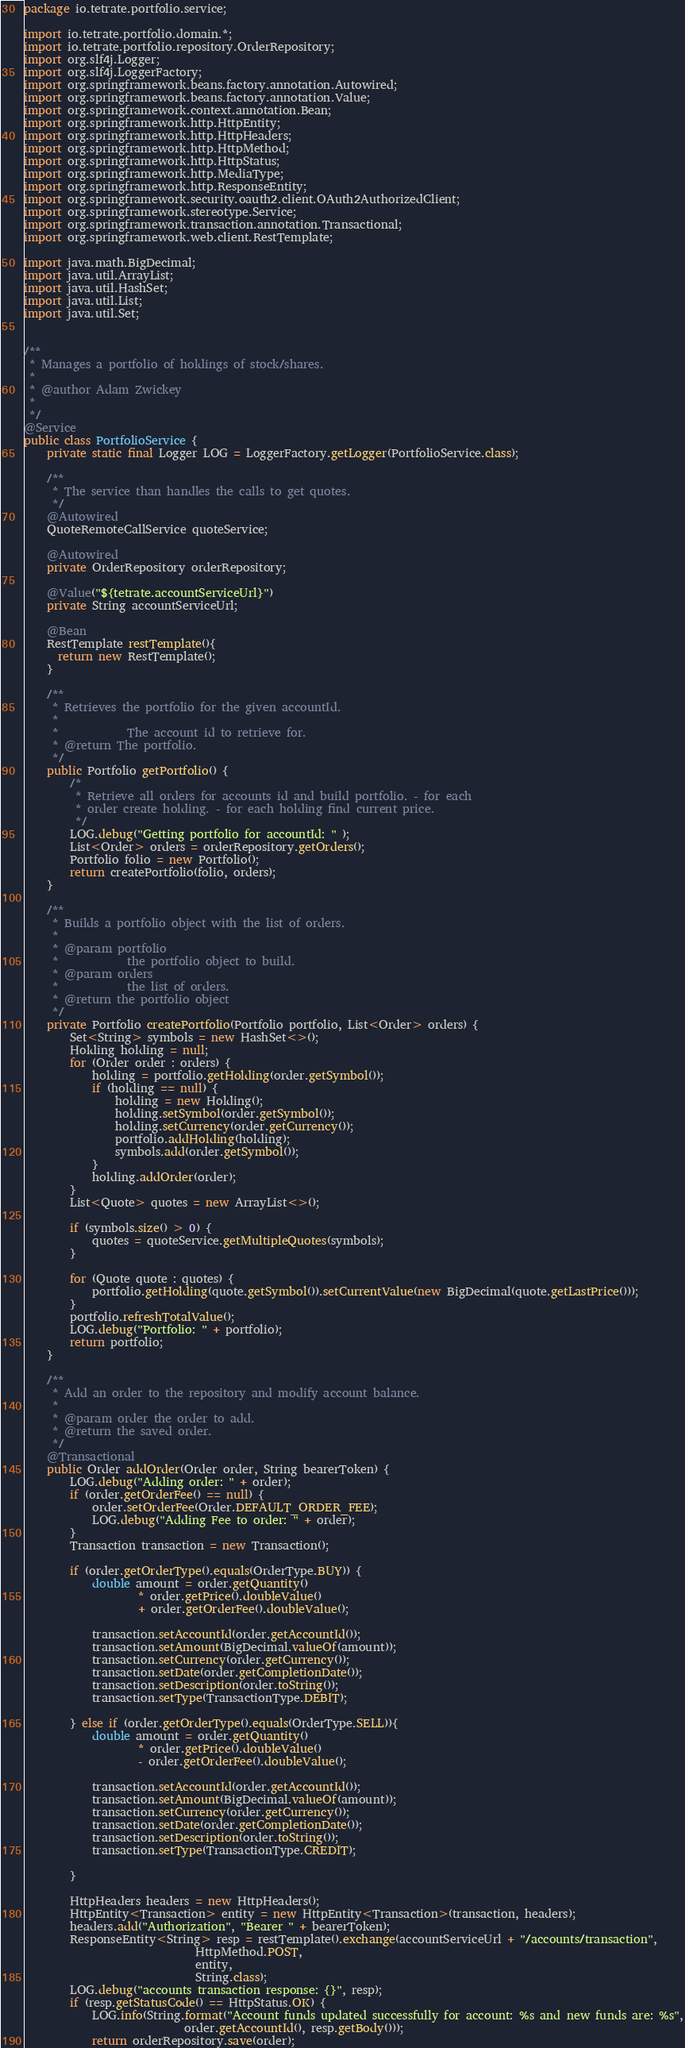<code> <loc_0><loc_0><loc_500><loc_500><_Java_>package io.tetrate.portfolio.service;

import io.tetrate.portfolio.domain.*;
import io.tetrate.portfolio.repository.OrderRepository;
import org.slf4j.Logger;
import org.slf4j.LoggerFactory;
import org.springframework.beans.factory.annotation.Autowired;
import org.springframework.beans.factory.annotation.Value;
import org.springframework.context.annotation.Bean;
import org.springframework.http.HttpEntity;
import org.springframework.http.HttpHeaders;
import org.springframework.http.HttpMethod;
import org.springframework.http.HttpStatus;
import org.springframework.http.MediaType;
import org.springframework.http.ResponseEntity;
import org.springframework.security.oauth2.client.OAuth2AuthorizedClient;
import org.springframework.stereotype.Service;
import org.springframework.transaction.annotation.Transactional;
import org.springframework.web.client.RestTemplate;

import java.math.BigDecimal;
import java.util.ArrayList;
import java.util.HashSet;
import java.util.List;
import java.util.Set;


/**
 * Manages a portfolio of holdings of stock/shares.
 * 
 * @author Adam Zwickey
 *
 */
@Service
public class PortfolioService {
	private static final Logger LOG = LoggerFactory.getLogger(PortfolioService.class);

	/**
	 * The service than handles the calls to get quotes.
	 */
	@Autowired
	QuoteRemoteCallService quoteService;

	@Autowired
	private OrderRepository orderRepository;

	@Value("${tetrate.accountServiceUrl}")
    private String accountServiceUrl;

    @Bean
    RestTemplate restTemplate(){
      return new RestTemplate();
    }

	/**
	 * Retrieves the portfolio for the given accountId.
	 *
	 *            The account id to retrieve for.
	 * @return The portfolio.
	 */
	public Portfolio getPortfolio() {
		/*
		 * Retrieve all orders for accounts id and build portfolio. - for each
		 * order create holding. - for each holding find current price.
		 */
		LOG.debug("Getting portfolio for accountId: " );
		List<Order> orders = orderRepository.getOrders();
		Portfolio folio = new Portfolio();
		return createPortfolio(folio, orders);
	}

	/**
	 * Builds a portfolio object with the list of orders.
	 * 
	 * @param portfolio
	 *            the portfolio object to build.
	 * @param orders
	 *            the list of orders.
	 * @return the portfolio object
	 */
	private Portfolio createPortfolio(Portfolio portfolio, List<Order> orders) {
		Set<String> symbols = new HashSet<>();
		Holding holding = null;
		for (Order order : orders) {
			holding = portfolio.getHolding(order.getSymbol());
			if (holding == null) {
				holding = new Holding();
				holding.setSymbol(order.getSymbol());
				holding.setCurrency(order.getCurrency());
				portfolio.addHolding(holding);
				symbols.add(order.getSymbol());
			}
			holding.addOrder(order);
		}
		List<Quote> quotes = new ArrayList<>();
		
		if (symbols.size() > 0) {
			quotes = quoteService.getMultipleQuotes(symbols);
		}

		for (Quote quote : quotes) {
			portfolio.getHolding(quote.getSymbol()).setCurrentValue(new BigDecimal(quote.getLastPrice()));
		}
		portfolio.refreshTotalValue();
		LOG.debug("Portfolio: " + portfolio);
		return portfolio;
	}

	/**
	 * Add an order to the repository and modify account balance.
	 * 
	 * @param order the order to add.
	 * @return the saved order.
	 */
	@Transactional
	public Order addOrder(Order order, String bearerToken) {
		LOG.debug("Adding order: " + order);
		if (order.getOrderFee() == null) {
			order.setOrderFee(Order.DEFAULT_ORDER_FEE);
			LOG.debug("Adding Fee to order: " + order);
		}
		Transaction transaction = new Transaction();
		
		if (order.getOrderType().equals(OrderType.BUY)) {
			double amount = order.getQuantity()
					* order.getPrice().doubleValue()
					+ order.getOrderFee().doubleValue();
			
			transaction.setAccountId(order.getAccountId());
			transaction.setAmount(BigDecimal.valueOf(amount));
			transaction.setCurrency(order.getCurrency());
			transaction.setDate(order.getCompletionDate());
			transaction.setDescription(order.toString());
			transaction.setType(TransactionType.DEBIT);
			
		} else if (order.getOrderType().equals(OrderType.SELL)){
			double amount = order.getQuantity()
					* order.getPrice().doubleValue()
					- order.getOrderFee().doubleValue();
			
			transaction.setAccountId(order.getAccountId());
			transaction.setAmount(BigDecimal.valueOf(amount));
			transaction.setCurrency(order.getCurrency());
			transaction.setDate(order.getCompletionDate());
			transaction.setDescription(order.toString());
			transaction.setType(TransactionType.CREDIT);
			
		}

		HttpHeaders headers = new HttpHeaders();
		HttpEntity<Transaction> entity = new HttpEntity<Transaction>(transaction, headers);
		headers.add("Authorization", "Bearer " + bearerToken);
		ResponseEntity<String> resp = restTemplate().exchange(accountServiceUrl + "/accounts/transaction", 
							  HttpMethod.POST, 
							  entity, 
							  String.class);
		LOG.debug("accounts transaction response: {}", resp);    
		if (resp.getStatusCode() == HttpStatus.OK) {
			LOG.info(String.format("Account funds updated successfully for account: %s and new funds are: %s",
							order.getAccountId(), resp.getBody()));
			return orderRepository.save(order);</code> 